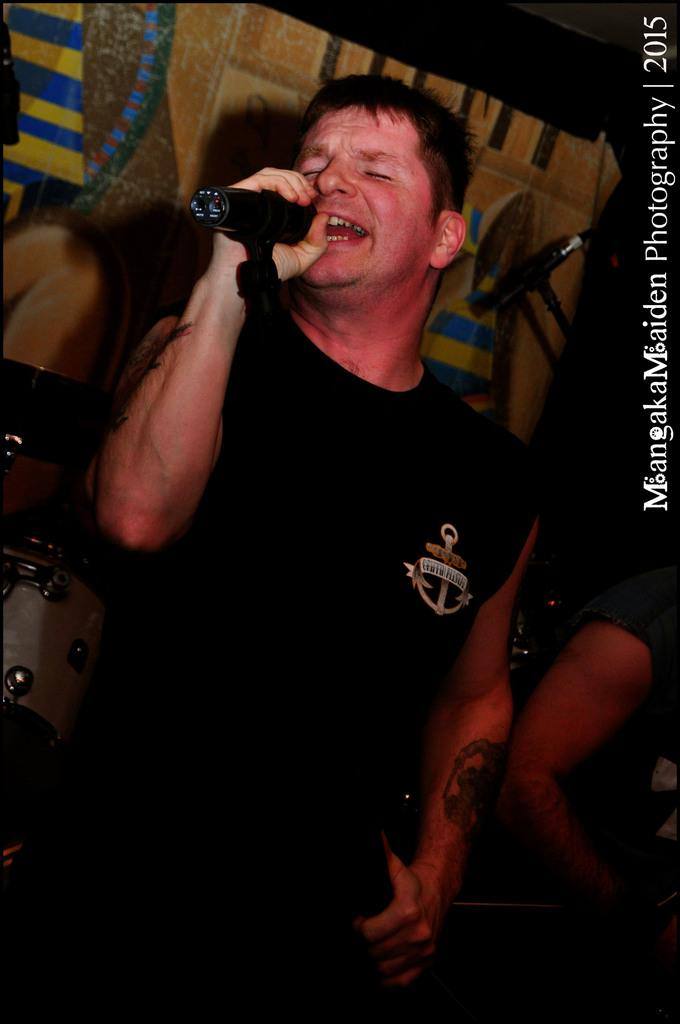What is the man in the image doing? The man is singing in the image. What is the man holding while singing? The man is holding a microphone. What is the man wearing? The man is wearing a black dress. What can be seen in the background of the image? There is a curtain in the background of the image. What is located to the left of the man? There is a band to the left of the man. How many cacti are visible in the image? There are no cacti present in the image. What type of sand can be seen on the floor in the image? There is no sand visible in the image; it is a man singing with a band in the background. 